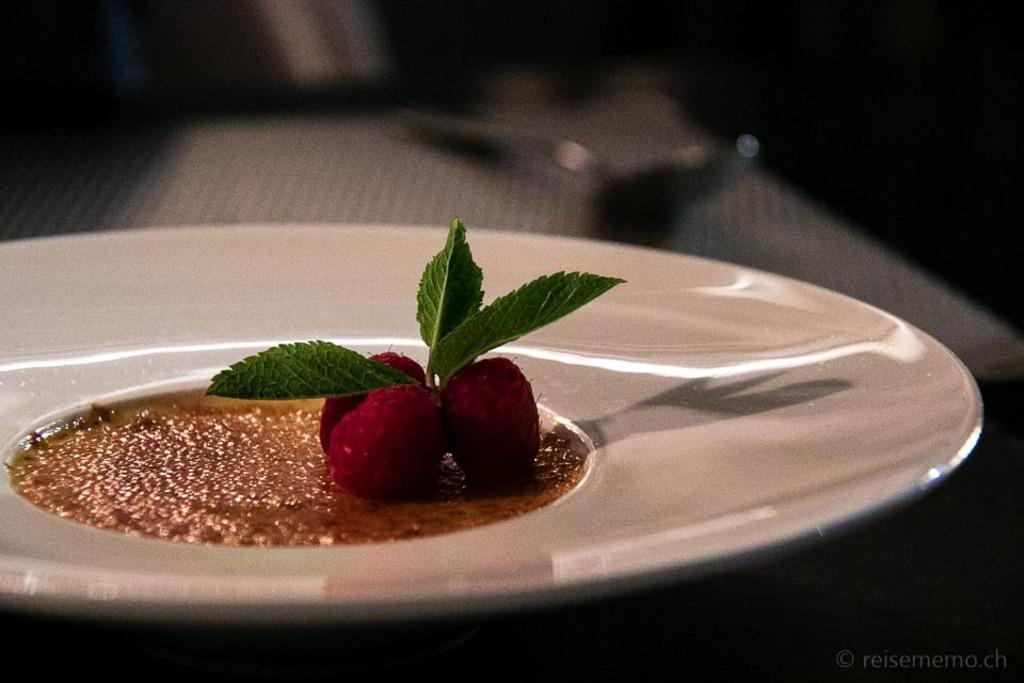What type of fruit is present in the image? There are strawberries in the image. What herb is also visible in the image? There is mint in the image. What is the main dish featured in the image? There is a dessert in the image. What color is the plate on which the items are placed? The plate is white. Where is the plate located in the image? The plate is kept on a table. What can be seen in the top right corner of the image? There is darkness in the top right corner of the image. What type of tub is visible in the image? There is no tub present in the image. How many pages can be seen in the image? There are no pages present in the image. What type of wilderness can be seen in the image? There is no wilderness present in the image. 